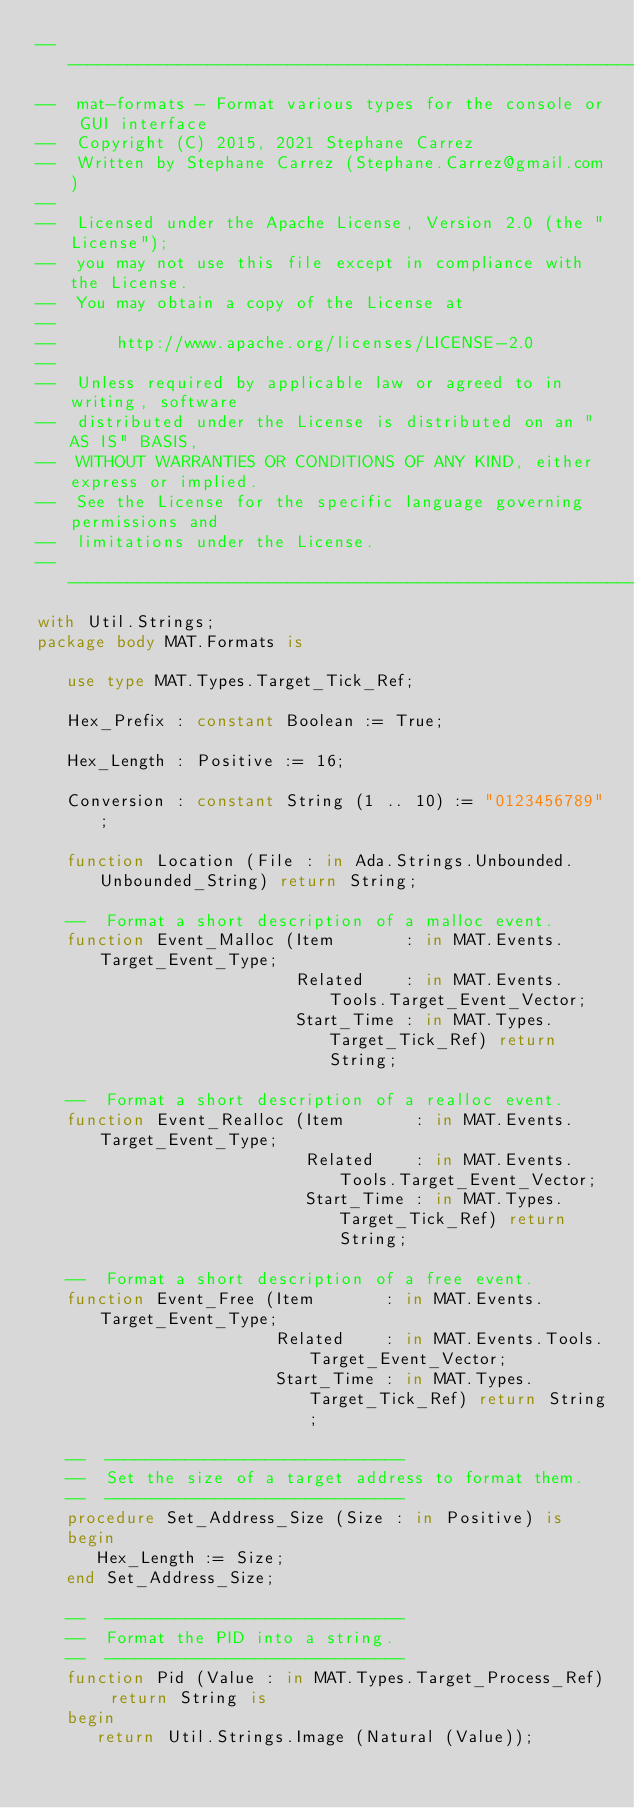<code> <loc_0><loc_0><loc_500><loc_500><_Ada_>-----------------------------------------------------------------------
--  mat-formats - Format various types for the console or GUI interface
--  Copyright (C) 2015, 2021 Stephane Carrez
--  Written by Stephane Carrez (Stephane.Carrez@gmail.com)
--
--  Licensed under the Apache License, Version 2.0 (the "License");
--  you may not use this file except in compliance with the License.
--  You may obtain a copy of the License at
--
--      http://www.apache.org/licenses/LICENSE-2.0
--
--  Unless required by applicable law or agreed to in writing, software
--  distributed under the License is distributed on an "AS IS" BASIS,
--  WITHOUT WARRANTIES OR CONDITIONS OF ANY KIND, either express or implied.
--  See the License for the specific language governing permissions and
--  limitations under the License.
-----------------------------------------------------------------------
with Util.Strings;
package body MAT.Formats is

   use type MAT.Types.Target_Tick_Ref;

   Hex_Prefix : constant Boolean := True;

   Hex_Length : Positive := 16;

   Conversion : constant String (1 .. 10) := "0123456789";

   function Location (File : in Ada.Strings.Unbounded.Unbounded_String) return String;

   --  Format a short description of a malloc event.
   function Event_Malloc (Item       : in MAT.Events.Target_Event_Type;
                          Related    : in MAT.Events.Tools.Target_Event_Vector;
                          Start_Time : in MAT.Types.Target_Tick_Ref) return String;

   --  Format a short description of a realloc event.
   function Event_Realloc (Item       : in MAT.Events.Target_Event_Type;
                           Related    : in MAT.Events.Tools.Target_Event_Vector;
                           Start_Time : in MAT.Types.Target_Tick_Ref) return String;

   --  Format a short description of a free event.
   function Event_Free (Item       : in MAT.Events.Target_Event_Type;
                        Related    : in MAT.Events.Tools.Target_Event_Vector;
                        Start_Time : in MAT.Types.Target_Tick_Ref) return String;

   --  ------------------------------
   --  Set the size of a target address to format them.
   --  ------------------------------
   procedure Set_Address_Size (Size : in Positive) is
   begin
      Hex_Length := Size;
   end Set_Address_Size;

   --  ------------------------------
   --  Format the PID into a string.
   --  ------------------------------
   function Pid (Value : in MAT.Types.Target_Process_Ref) return String is
   begin
      return Util.Strings.Image (Natural (Value));</code> 